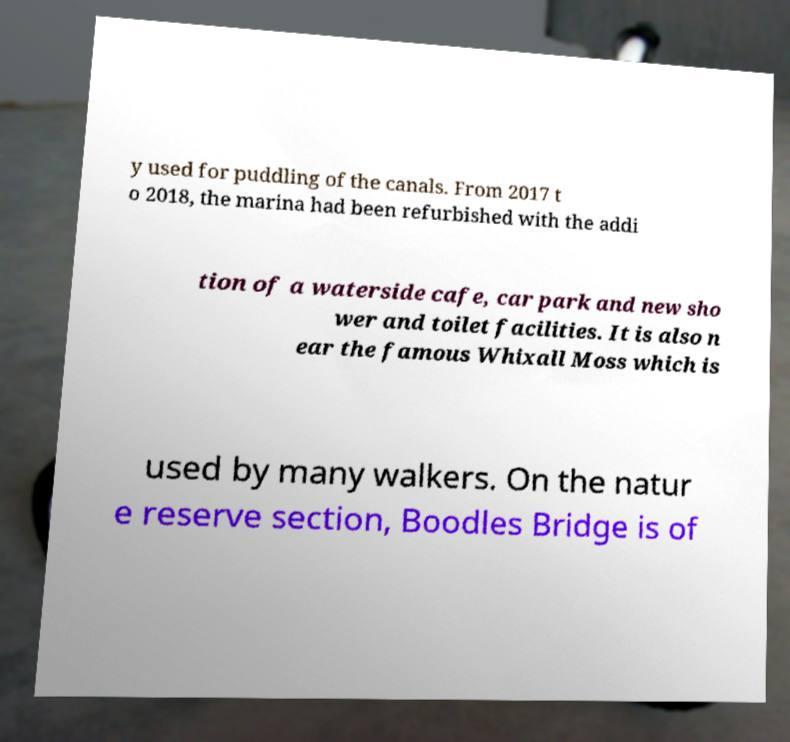I need the written content from this picture converted into text. Can you do that? y used for puddling of the canals. From 2017 t o 2018, the marina had been refurbished with the addi tion of a waterside cafe, car park and new sho wer and toilet facilities. It is also n ear the famous Whixall Moss which is used by many walkers. On the natur e reserve section, Boodles Bridge is of 